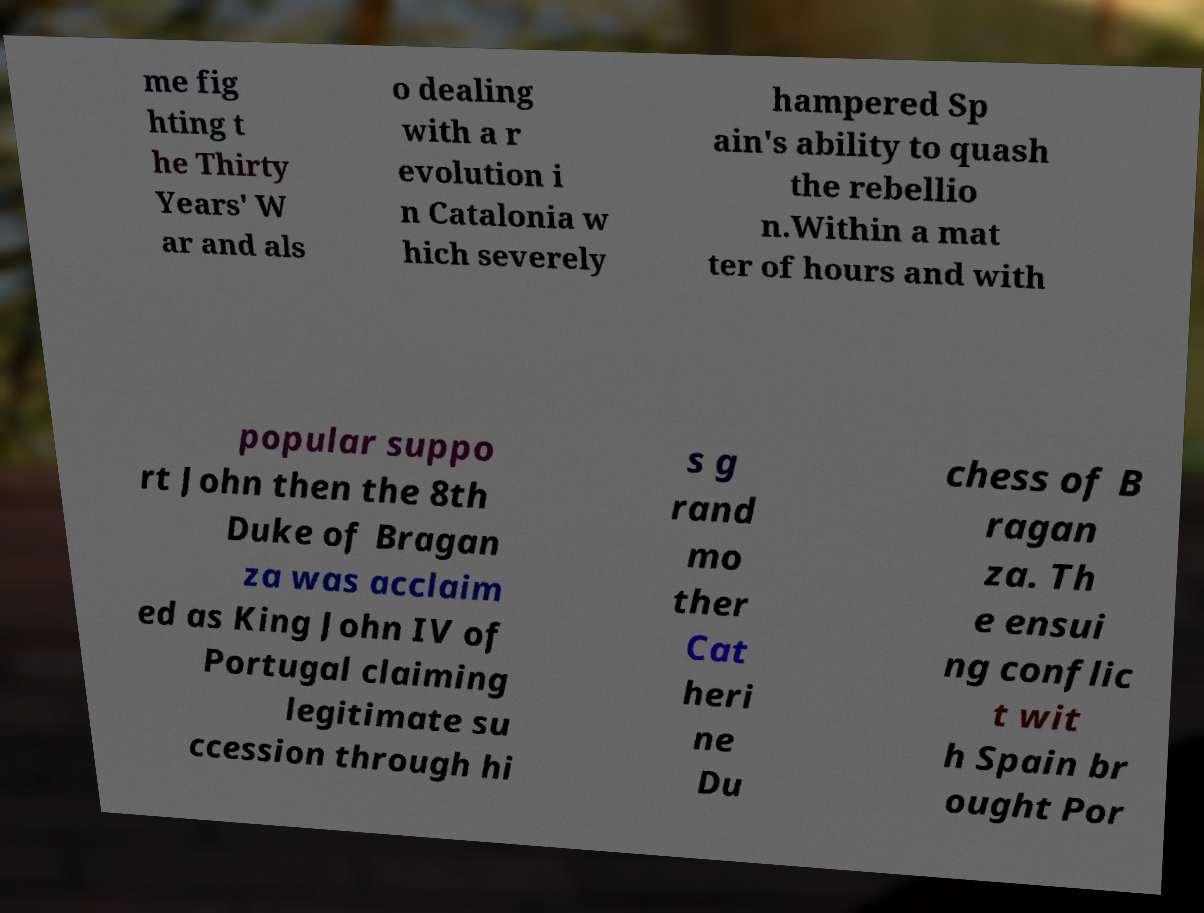Can you read and provide the text displayed in the image?This photo seems to have some interesting text. Can you extract and type it out for me? me fig hting t he Thirty Years' W ar and als o dealing with a r evolution i n Catalonia w hich severely hampered Sp ain's ability to quash the rebellio n.Within a mat ter of hours and with popular suppo rt John then the 8th Duke of Bragan za was acclaim ed as King John IV of Portugal claiming legitimate su ccession through hi s g rand mo ther Cat heri ne Du chess of B ragan za. Th e ensui ng conflic t wit h Spain br ought Por 